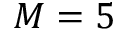Convert formula to latex. <formula><loc_0><loc_0><loc_500><loc_500>M = 5</formula> 